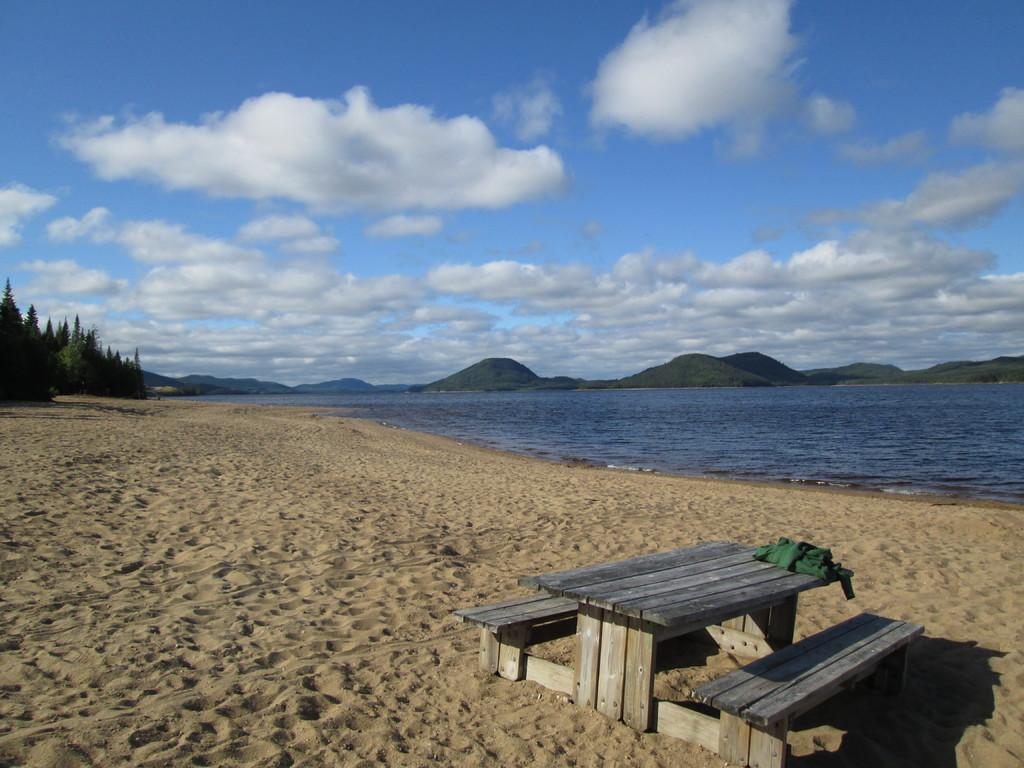What type of seating is present in the image? There is a bench in the image. What is the other object made of in the image? There is a cloth in the image. What type of natural environment is visible in the image? Trees, water, and a mountain are visible in the image. What is visible in the background of the image? The sky is visible in the background of the image. What can be seen in the sky? Clouds are present in the sky. Where is the curtain located in the image? There is no curtain present in the image. What type of cactus can be seen growing near the water in the image? There is no cactus present in the image. 